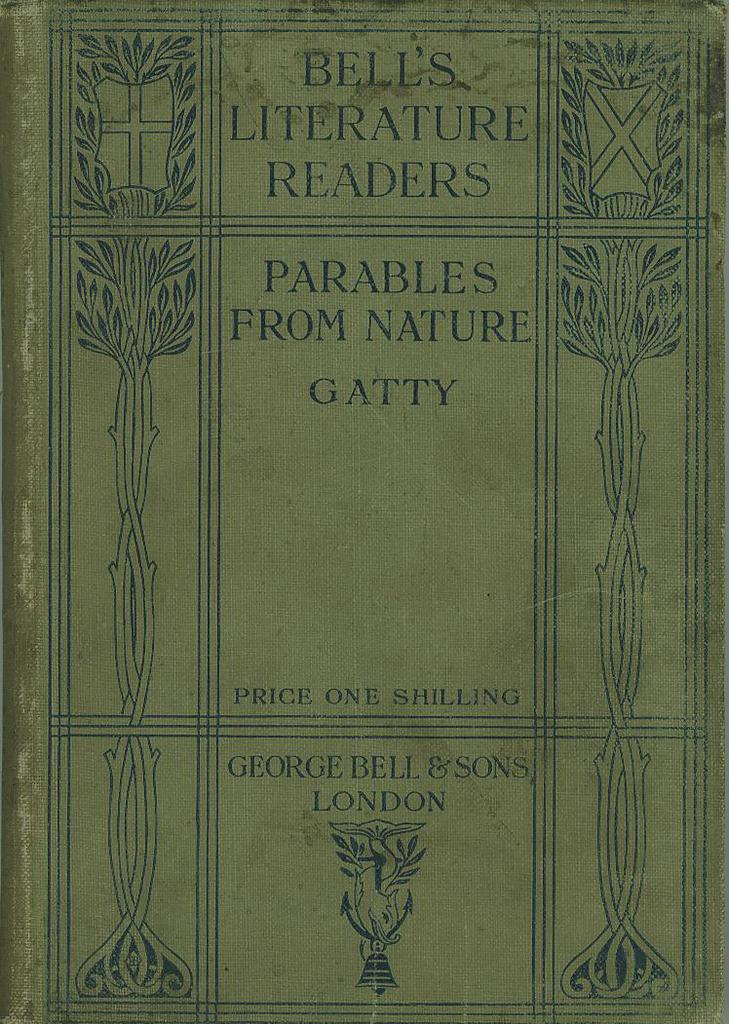<image>
Summarize the visual content of the image. Cover of a book that says LONDON near the bottom. 